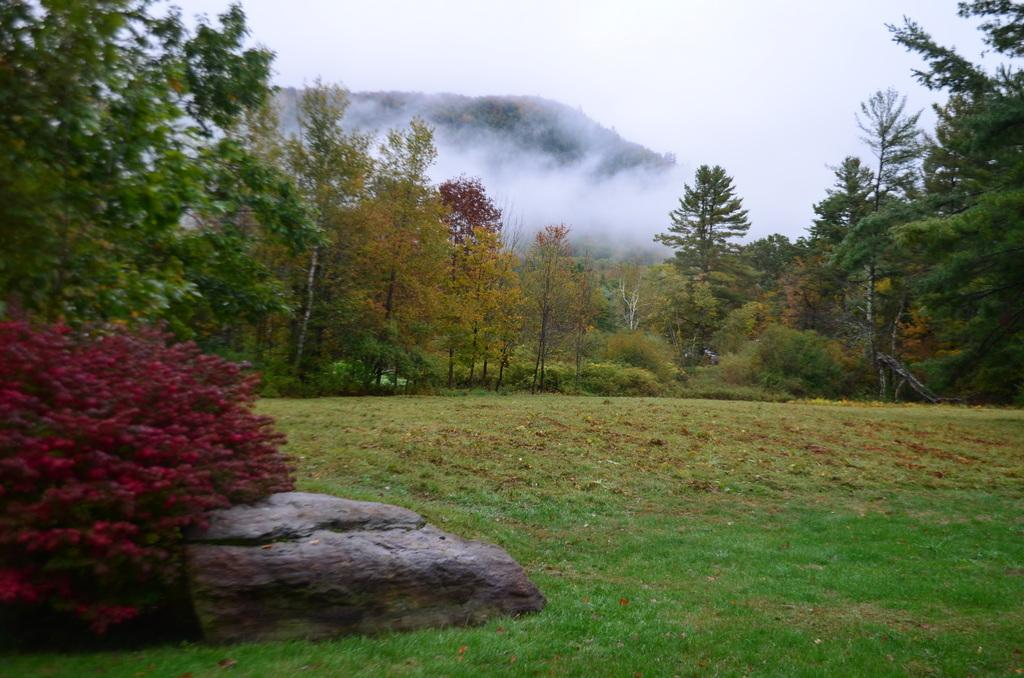What type of vegetation is present in the image? There are tall trees in the image. What colors can be seen on the trees? The trees have green and yellow colors. What geographical features are visible in the image? There is a group of hills in the image. What type of terrain is present on the hills? The hills have grassy land. What type of government is depicted in the image? There is no depiction of a government in the image; it features tall trees and a group of hills. How does the image show the concept of stopping? The image does not show the concept of stopping; it is a static representation of trees and hills. 